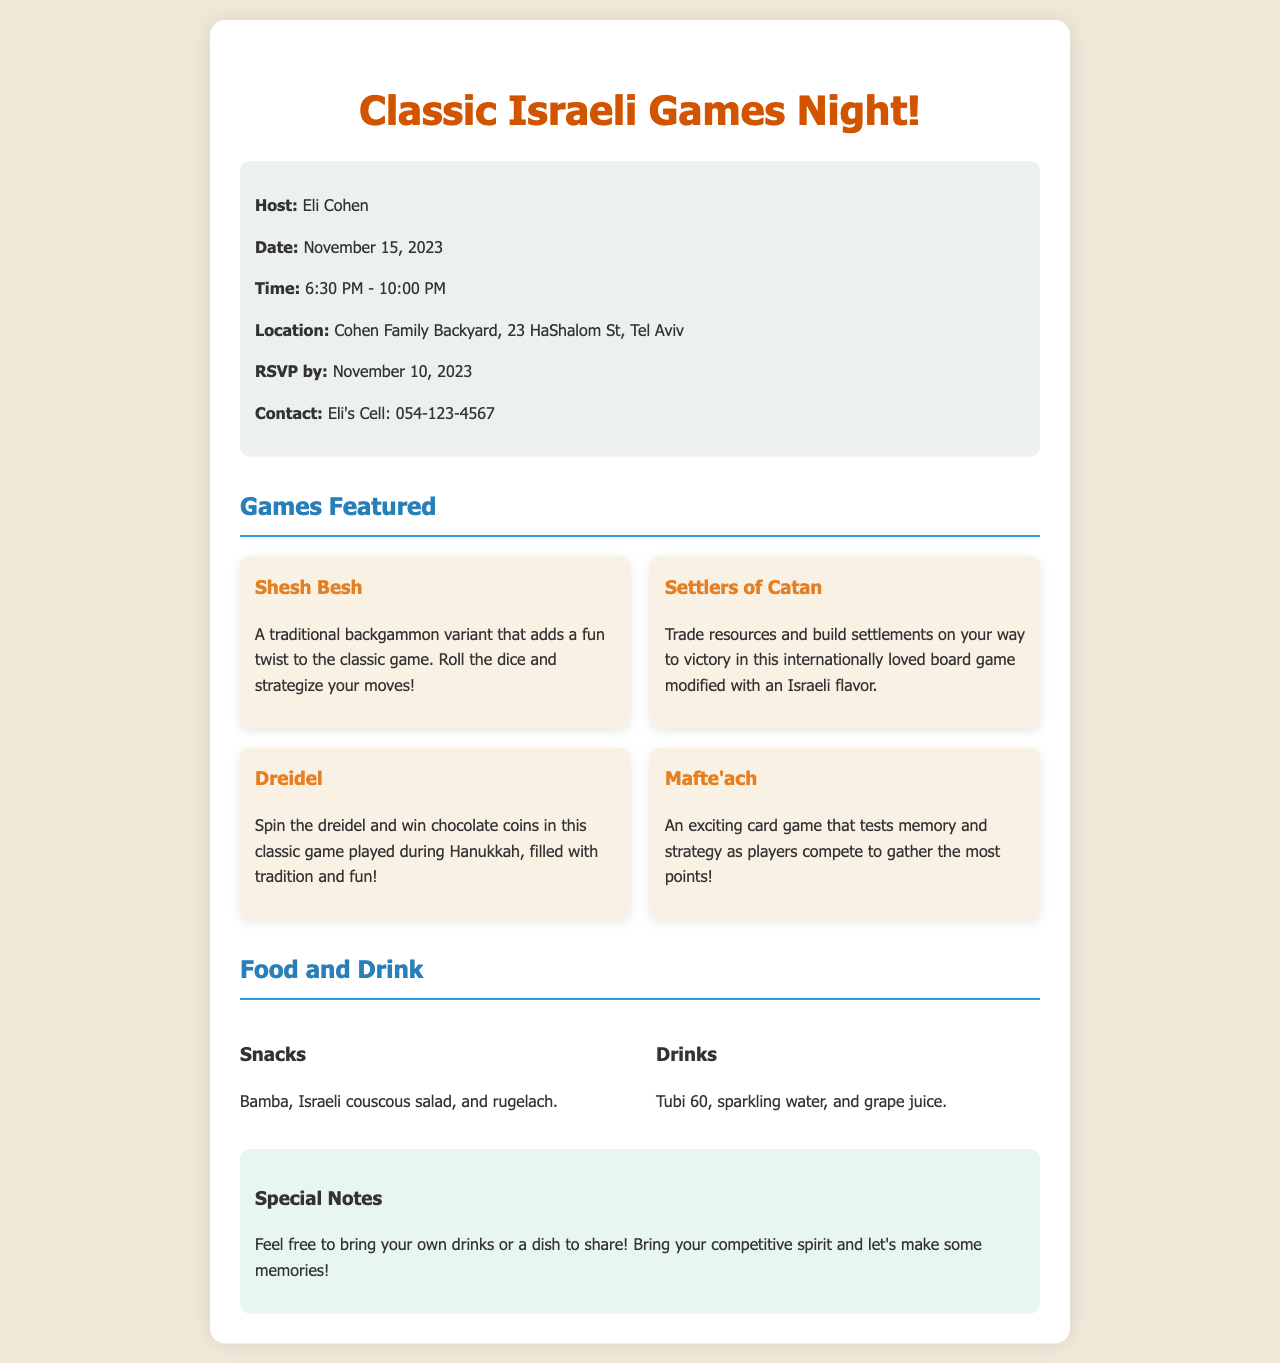What is the host's name? The host's name is listed at the top of the document under the information section.
Answer: Eli Cohen When is the Game Night scheduled to take place? The date of the Game Night is specified in the document.
Answer: November 15, 2023 What time does the event start? The starting time is mentioned in the information section of the document.
Answer: 6:30 PM What type of game is Shesh Besh? The type of game is described in the games section of the document.
Answer: Backgammon variant What is mentioned as a special note regarding food? The notes section includes information about bringing additional items.
Answer: Bring your own drinks or a dish to share How many games are featured in the document? The number of games is determined by counting the game listings in the document.
Answer: Four What snacks will be served at the event? The snacks offered are listed in the food and drink section of the document.
Answer: Bamba, Israeli couscous salad, and rugelach Who should be contacted for RSVP? The contact information for RSVP is provided in the information section of the document.
Answer: Eli's Cell: 054-123-4567 Where is the location of the event? The event's location is detailed in the information section.
Answer: Cohen Family Backyard, 23 HaShalom St, Tel Aviv 